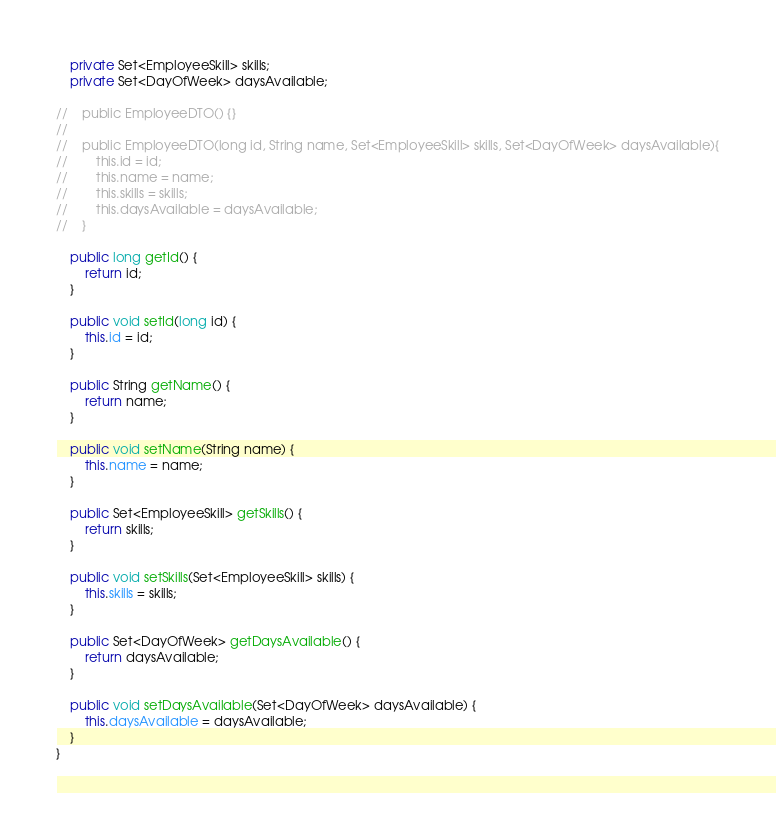Convert code to text. <code><loc_0><loc_0><loc_500><loc_500><_Java_>    private Set<EmployeeSkill> skills;
    private Set<DayOfWeek> daysAvailable;

//    public EmployeeDTO() {}
//
//    public EmployeeDTO(long id, String name, Set<EmployeeSkill> skills, Set<DayOfWeek> daysAvailable){
//        this.id = id;
//        this.name = name;
//        this.skills = skills;
//        this.daysAvailable = daysAvailable;
//    }

    public long getId() {
        return id;
    }

    public void setId(long id) {
        this.id = id;
    }

    public String getName() {
        return name;
    }

    public void setName(String name) {
        this.name = name;
    }

    public Set<EmployeeSkill> getSkills() {
        return skills;
    }

    public void setSkills(Set<EmployeeSkill> skills) {
        this.skills = skills;
    }

    public Set<DayOfWeek> getDaysAvailable() {
        return daysAvailable;
    }

    public void setDaysAvailable(Set<DayOfWeek> daysAvailable) {
        this.daysAvailable = daysAvailable;
    }
}
</code> 